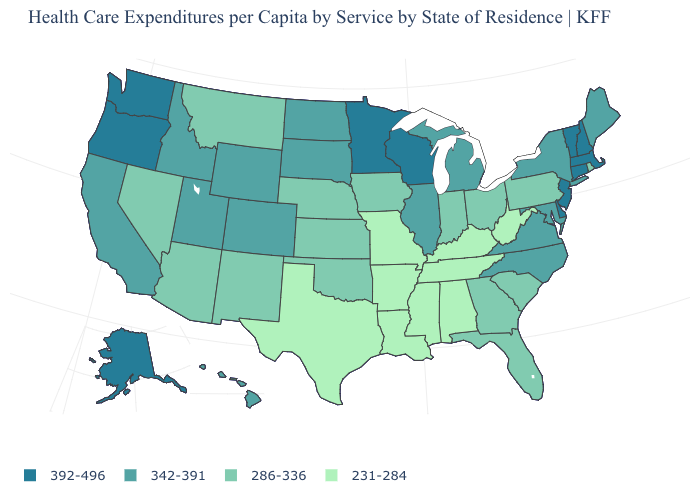Does the first symbol in the legend represent the smallest category?
Give a very brief answer. No. Is the legend a continuous bar?
Keep it brief. No. Name the states that have a value in the range 286-336?
Keep it brief. Arizona, Florida, Georgia, Indiana, Iowa, Kansas, Montana, Nebraska, Nevada, New Mexico, Ohio, Oklahoma, Pennsylvania, Rhode Island, South Carolina. Which states hav the highest value in the West?
Quick response, please. Alaska, Oregon, Washington. Name the states that have a value in the range 231-284?
Concise answer only. Alabama, Arkansas, Kentucky, Louisiana, Mississippi, Missouri, Tennessee, Texas, West Virginia. Does Arkansas have the highest value in the South?
Give a very brief answer. No. Does Wisconsin have the lowest value in the MidWest?
Be succinct. No. What is the value of Alabama?
Concise answer only. 231-284. Name the states that have a value in the range 342-391?
Be succinct. California, Colorado, Hawaii, Idaho, Illinois, Maine, Maryland, Michigan, New York, North Carolina, North Dakota, South Dakota, Utah, Virginia, Wyoming. Name the states that have a value in the range 392-496?
Give a very brief answer. Alaska, Connecticut, Delaware, Massachusetts, Minnesota, New Hampshire, New Jersey, Oregon, Vermont, Washington, Wisconsin. What is the highest value in the USA?
Keep it brief. 392-496. Name the states that have a value in the range 286-336?
Answer briefly. Arizona, Florida, Georgia, Indiana, Iowa, Kansas, Montana, Nebraska, Nevada, New Mexico, Ohio, Oklahoma, Pennsylvania, Rhode Island, South Carolina. Name the states that have a value in the range 231-284?
Concise answer only. Alabama, Arkansas, Kentucky, Louisiana, Mississippi, Missouri, Tennessee, Texas, West Virginia. Among the states that border Wisconsin , does Iowa have the lowest value?
Write a very short answer. Yes. Is the legend a continuous bar?
Short answer required. No. 